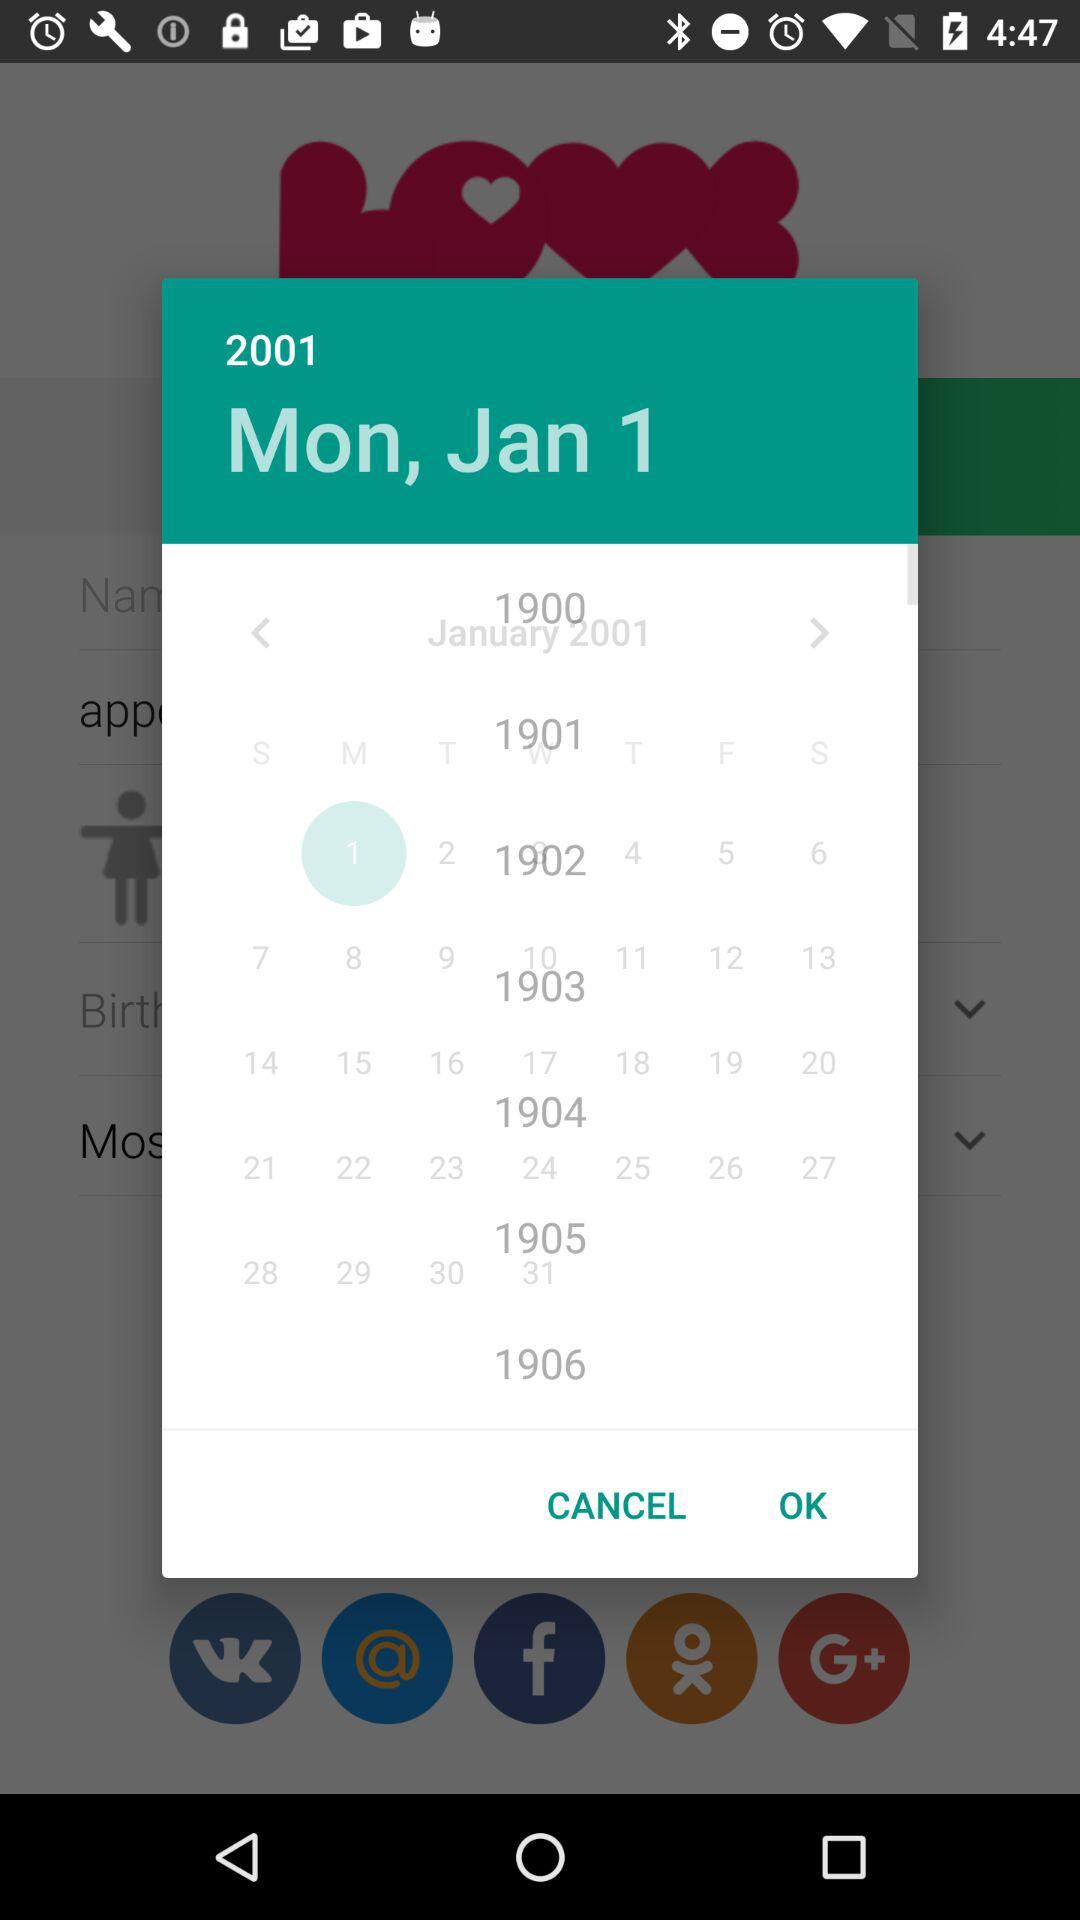What is the day? The day is Monday. 